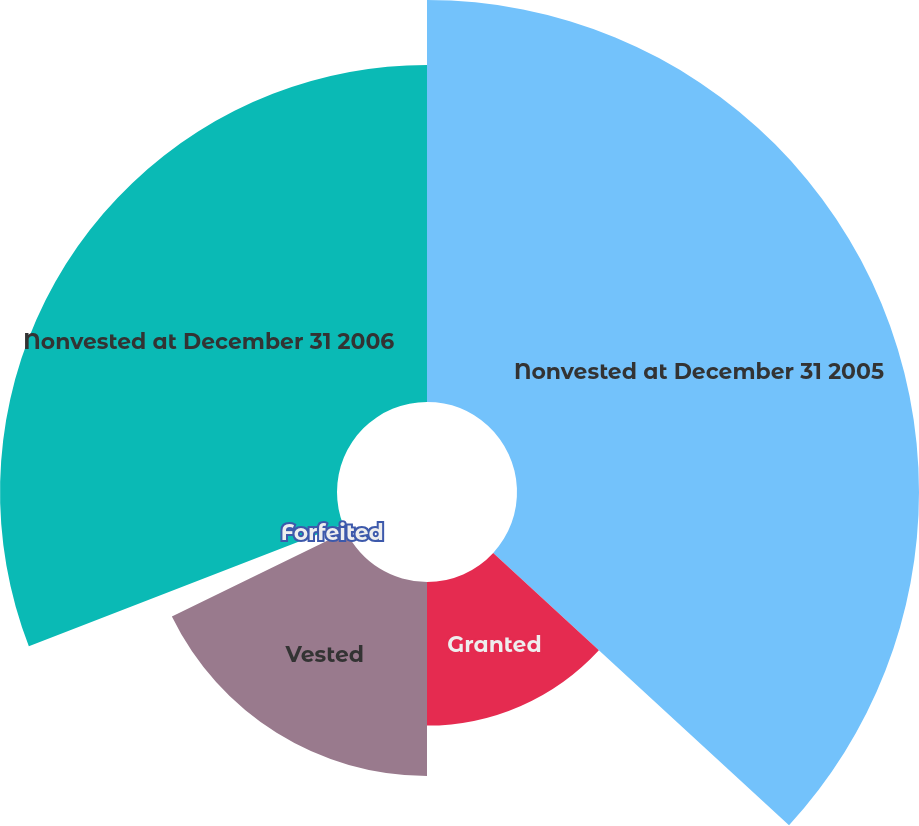<chart> <loc_0><loc_0><loc_500><loc_500><pie_chart><fcel>Nonvested at December 31 2005<fcel>Granted<fcel>Vested<fcel>Forfeited<fcel>Nonvested at December 31 2006<nl><fcel>36.84%<fcel>13.16%<fcel>17.77%<fcel>1.35%<fcel>30.88%<nl></chart> 